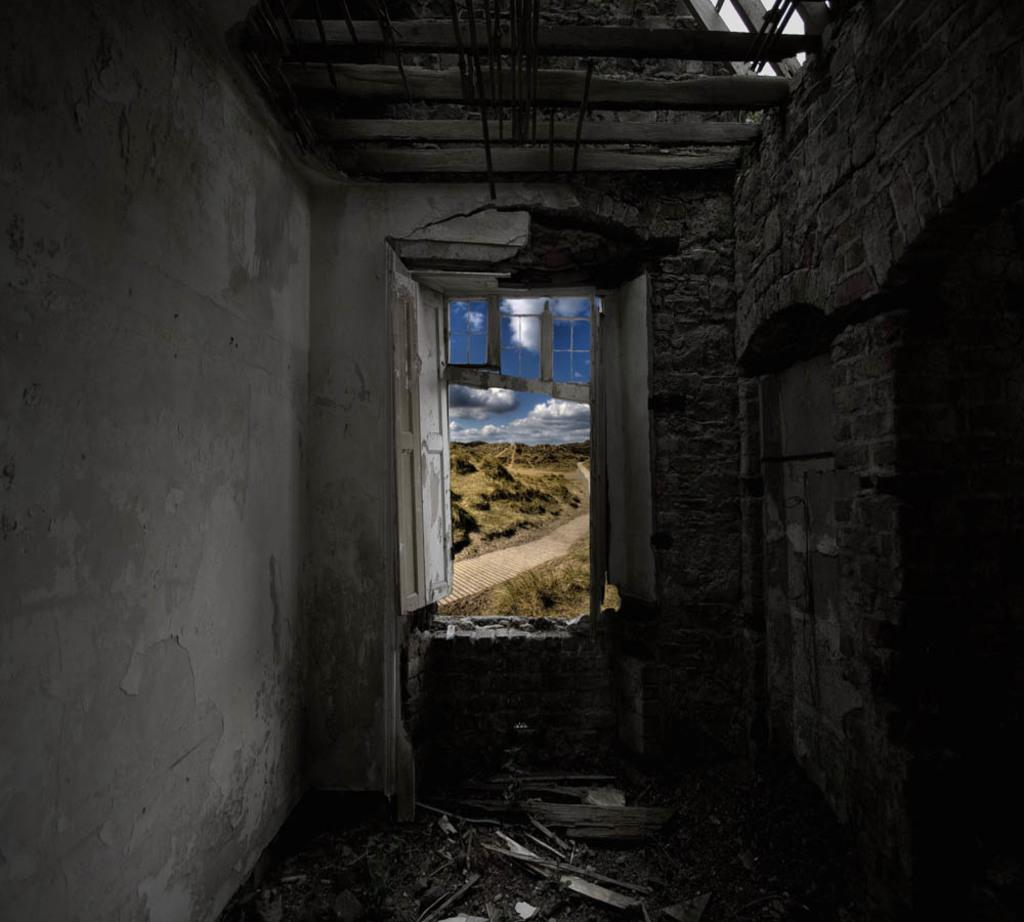What type of location is depicted in the image? The image is of the inside part of a house. Can you identify any specific features of the house in the image? There is a window visible in the image. What else can be seen in the image besides the window? There are walls visible in the image. How many hydrants are visible in the image? There are no hydrants present in the image, as it is an interior view of a house. 